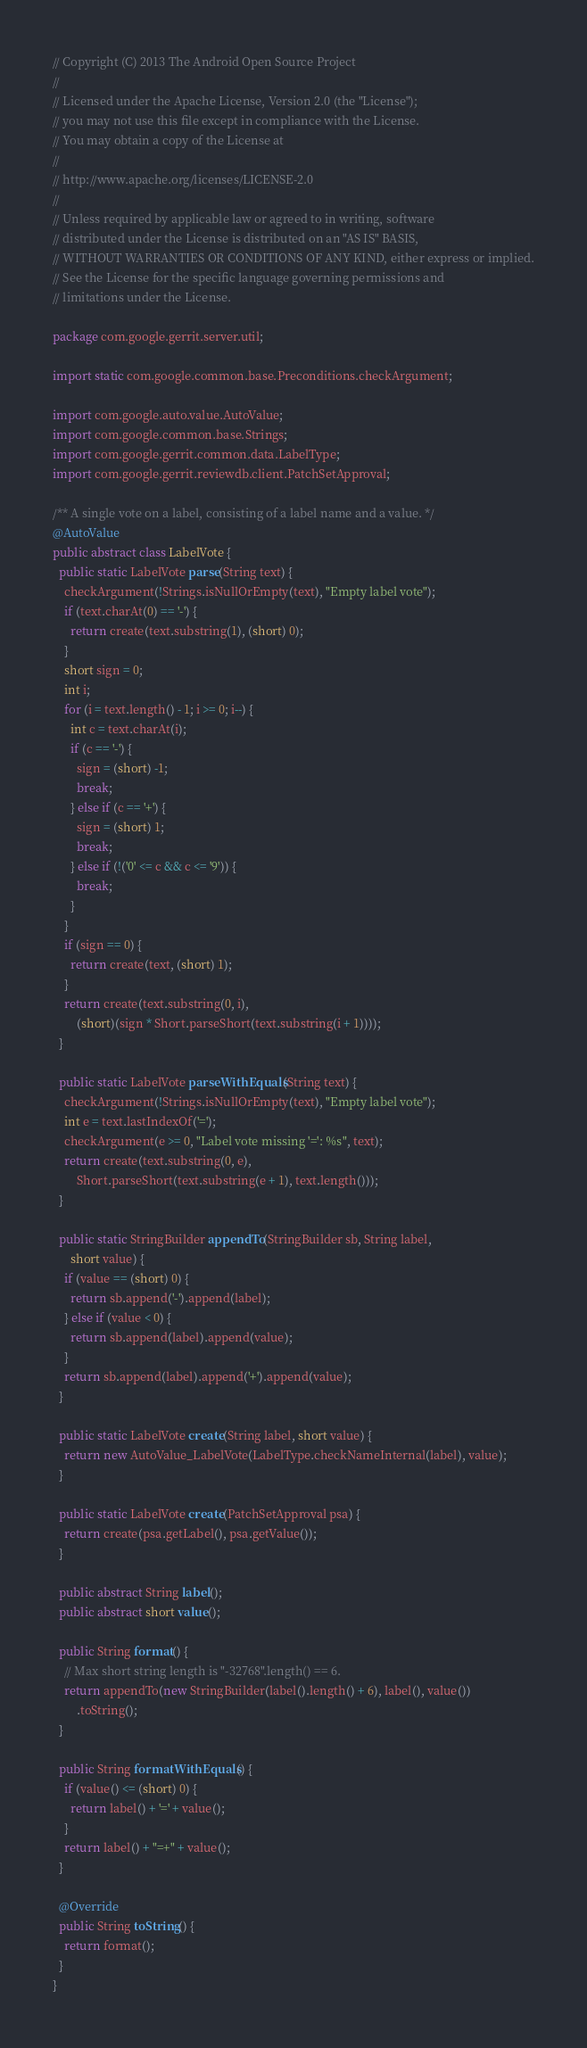Convert code to text. <code><loc_0><loc_0><loc_500><loc_500><_Java_>// Copyright (C) 2013 The Android Open Source Project
//
// Licensed under the Apache License, Version 2.0 (the "License");
// you may not use this file except in compliance with the License.
// You may obtain a copy of the License at
//
// http://www.apache.org/licenses/LICENSE-2.0
//
// Unless required by applicable law or agreed to in writing, software
// distributed under the License is distributed on an "AS IS" BASIS,
// WITHOUT WARRANTIES OR CONDITIONS OF ANY KIND, either express or implied.
// See the License for the specific language governing permissions and
// limitations under the License.

package com.google.gerrit.server.util;

import static com.google.common.base.Preconditions.checkArgument;

import com.google.auto.value.AutoValue;
import com.google.common.base.Strings;
import com.google.gerrit.common.data.LabelType;
import com.google.gerrit.reviewdb.client.PatchSetApproval;

/** A single vote on a label, consisting of a label name and a value. */
@AutoValue
public abstract class LabelVote {
  public static LabelVote parse(String text) {
    checkArgument(!Strings.isNullOrEmpty(text), "Empty label vote");
    if (text.charAt(0) == '-') {
      return create(text.substring(1), (short) 0);
    }
    short sign = 0;
    int i;
    for (i = text.length() - 1; i >= 0; i--) {
      int c = text.charAt(i);
      if (c == '-') {
        sign = (short) -1;
        break;
      } else if (c == '+') {
        sign = (short) 1;
        break;
      } else if (!('0' <= c && c <= '9')) {
        break;
      }
    }
    if (sign == 0) {
      return create(text, (short) 1);
    }
    return create(text.substring(0, i),
        (short)(sign * Short.parseShort(text.substring(i + 1))));
  }

  public static LabelVote parseWithEquals(String text) {
    checkArgument(!Strings.isNullOrEmpty(text), "Empty label vote");
    int e = text.lastIndexOf('=');
    checkArgument(e >= 0, "Label vote missing '=': %s", text);
    return create(text.substring(0, e),
        Short.parseShort(text.substring(e + 1), text.length()));
  }

  public static StringBuilder appendTo(StringBuilder sb, String label,
      short value) {
    if (value == (short) 0) {
      return sb.append('-').append(label);
    } else if (value < 0) {
      return sb.append(label).append(value);
    }
    return sb.append(label).append('+').append(value);
  }

  public static LabelVote create(String label, short value) {
    return new AutoValue_LabelVote(LabelType.checkNameInternal(label), value);
  }

  public static LabelVote create(PatchSetApproval psa) {
    return create(psa.getLabel(), psa.getValue());
  }

  public abstract String label();
  public abstract short value();

  public String format() {
    // Max short string length is "-32768".length() == 6.
    return appendTo(new StringBuilder(label().length() + 6), label(), value())
        .toString();
  }

  public String formatWithEquals() {
    if (value() <= (short) 0) {
      return label() + '=' + value();
    }
    return label() + "=+" + value();
  }

  @Override
  public String toString() {
    return format();
  }
}
</code> 